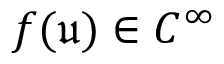Convert formula to latex. <formula><loc_0><loc_0><loc_500><loc_500>f ( \mathfrak { u } ) \in C ^ { \infty }</formula> 